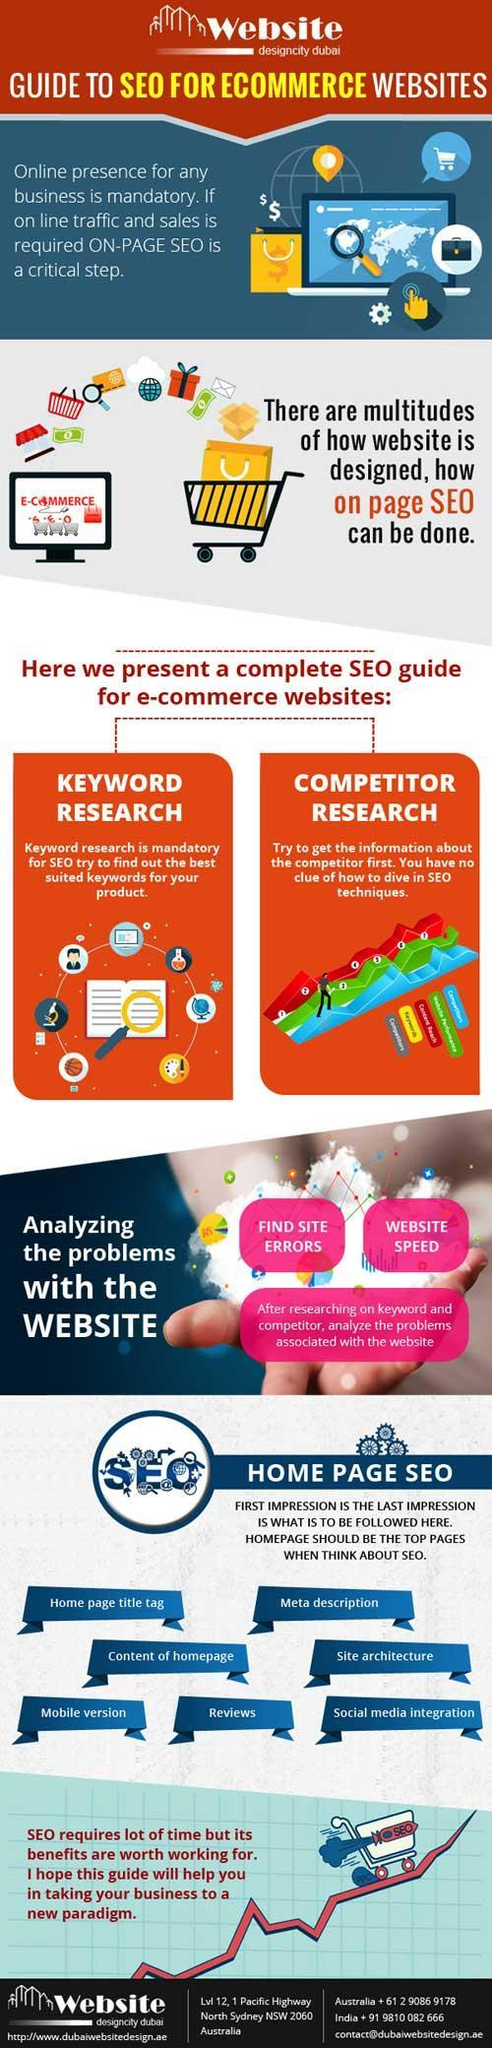What helps SEO find keywords suitable for your product?
Answer the question with a short phrase. Keyword research What is the second last tip mentioned that helps to improve homepage SEO? Reviews 